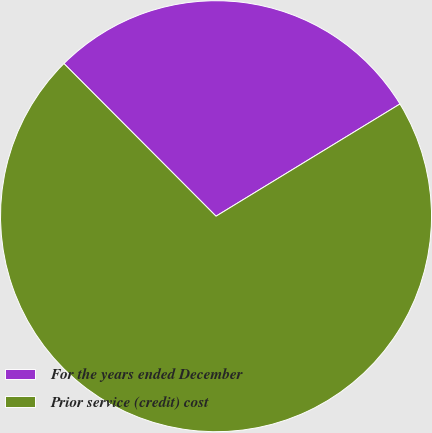Convert chart. <chart><loc_0><loc_0><loc_500><loc_500><pie_chart><fcel>For the years ended December<fcel>Prior service (credit) cost<nl><fcel>28.75%<fcel>71.25%<nl></chart> 